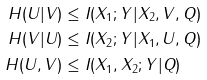<formula> <loc_0><loc_0><loc_500><loc_500>H ( U | V ) & \leq I ( X _ { 1 } ; Y | X _ { 2 } , V , Q ) \\ H ( V | U ) & \leq I ( X _ { 2 } ; Y | X _ { 1 } , U , Q ) \\ H ( U , V ) & \leq I ( X _ { 1 } , X _ { 2 } ; Y | Q )</formula> 